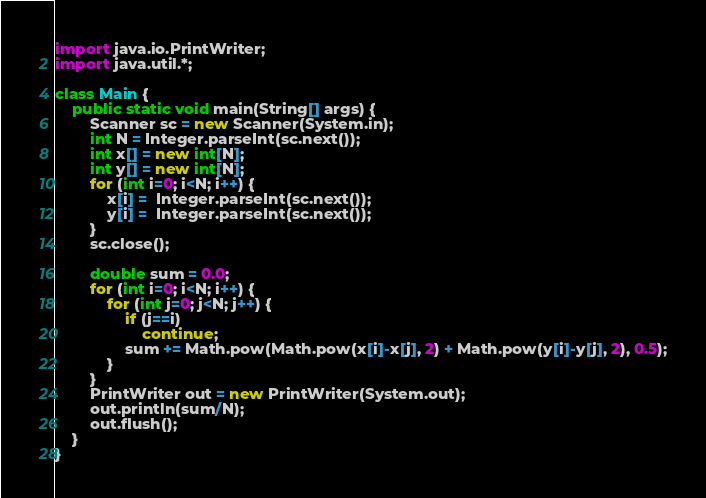Convert code to text. <code><loc_0><loc_0><loc_500><loc_500><_Java_>import java.io.PrintWriter;
import java.util.*;

class Main {
    public static void main(String[] args) {
        Scanner sc = new Scanner(System.in);
        int N = Integer.parseInt(sc.next());
        int x[] = new int[N];
        int y[] = new int[N];
        for (int i=0; i<N; i++) {
            x[i] =  Integer.parseInt(sc.next());
            y[i] =  Integer.parseInt(sc.next());
        }
        sc.close();

        double sum = 0.0;
        for (int i=0; i<N; i++) {
            for (int j=0; j<N; j++) {
                if (j==i)
                    continue;
                sum += Math.pow(Math.pow(x[i]-x[j], 2) + Math.pow(y[i]-y[j], 2), 0.5);
            }
        }
        PrintWriter out = new PrintWriter(System.out);
        out.println(sum/N);
        out.flush();
    }
}</code> 